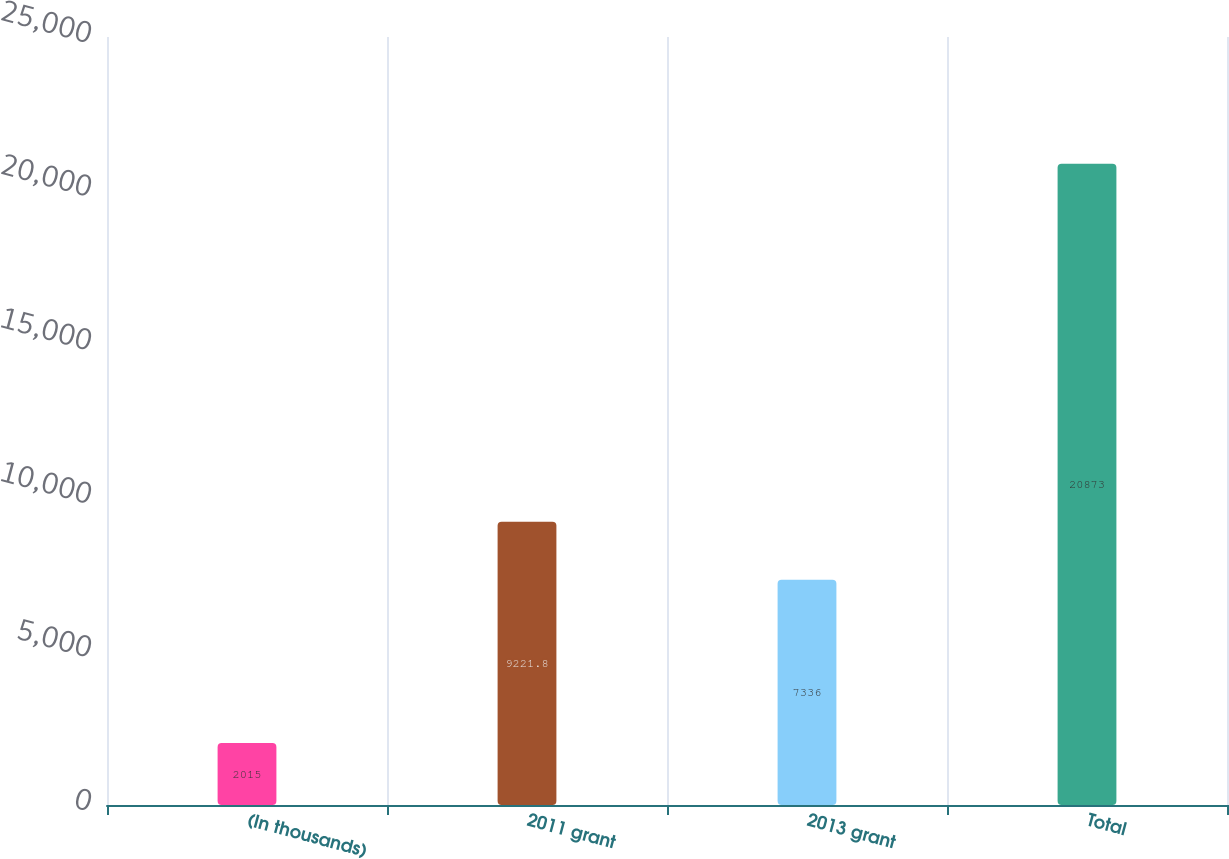<chart> <loc_0><loc_0><loc_500><loc_500><bar_chart><fcel>(In thousands)<fcel>2011 grant<fcel>2013 grant<fcel>Total<nl><fcel>2015<fcel>9221.8<fcel>7336<fcel>20873<nl></chart> 